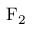<formula> <loc_0><loc_0><loc_500><loc_500>F _ { 2 }</formula> 